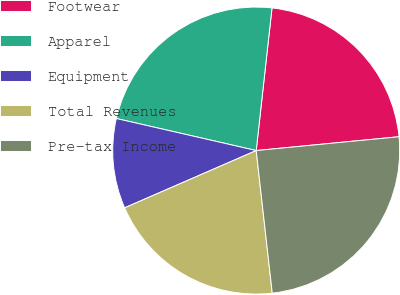Convert chart to OTSL. <chart><loc_0><loc_0><loc_500><loc_500><pie_chart><fcel>Footwear<fcel>Apparel<fcel>Equipment<fcel>Total Revenues<fcel>Pre-tax Income<nl><fcel>21.71%<fcel>23.17%<fcel>10.12%<fcel>20.25%<fcel>24.75%<nl></chart> 